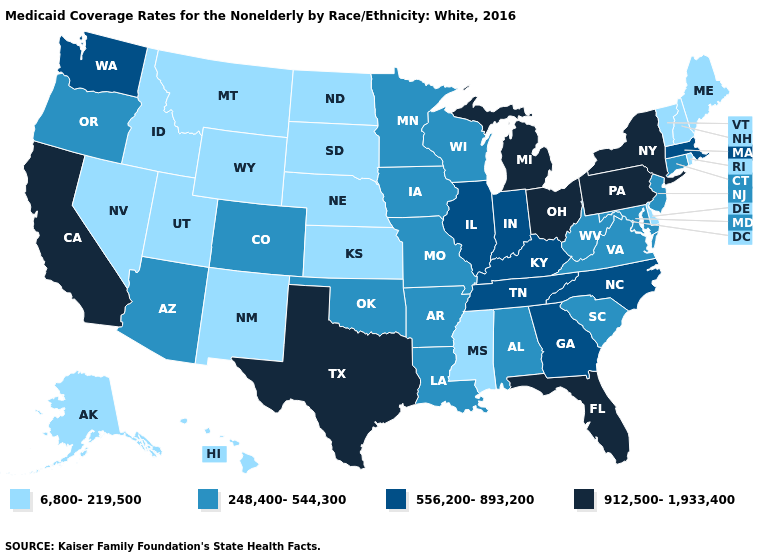Name the states that have a value in the range 6,800-219,500?
Write a very short answer. Alaska, Delaware, Hawaii, Idaho, Kansas, Maine, Mississippi, Montana, Nebraska, Nevada, New Hampshire, New Mexico, North Dakota, Rhode Island, South Dakota, Utah, Vermont, Wyoming. Does New York have the highest value in the USA?
Quick response, please. Yes. Which states have the highest value in the USA?
Write a very short answer. California, Florida, Michigan, New York, Ohio, Pennsylvania, Texas. What is the value of Maine?
Be succinct. 6,800-219,500. What is the value of South Carolina?
Answer briefly. 248,400-544,300. Does the map have missing data?
Answer briefly. No. What is the lowest value in states that border Missouri?
Short answer required. 6,800-219,500. Name the states that have a value in the range 248,400-544,300?
Answer briefly. Alabama, Arizona, Arkansas, Colorado, Connecticut, Iowa, Louisiana, Maryland, Minnesota, Missouri, New Jersey, Oklahoma, Oregon, South Carolina, Virginia, West Virginia, Wisconsin. Name the states that have a value in the range 556,200-893,200?
Be succinct. Georgia, Illinois, Indiana, Kentucky, Massachusetts, North Carolina, Tennessee, Washington. Name the states that have a value in the range 248,400-544,300?
Write a very short answer. Alabama, Arizona, Arkansas, Colorado, Connecticut, Iowa, Louisiana, Maryland, Minnesota, Missouri, New Jersey, Oklahoma, Oregon, South Carolina, Virginia, West Virginia, Wisconsin. Which states have the lowest value in the Northeast?
Write a very short answer. Maine, New Hampshire, Rhode Island, Vermont. Does the first symbol in the legend represent the smallest category?
Keep it brief. Yes. What is the lowest value in the South?
Concise answer only. 6,800-219,500. What is the value of Maryland?
Give a very brief answer. 248,400-544,300. 